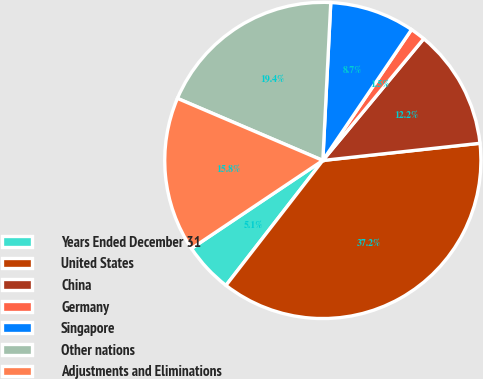<chart> <loc_0><loc_0><loc_500><loc_500><pie_chart><fcel>Years Ended December 31<fcel>United States<fcel>China<fcel>Germany<fcel>Singapore<fcel>Other nations<fcel>Adjustments and Eliminations<nl><fcel>5.11%<fcel>37.23%<fcel>12.25%<fcel>1.54%<fcel>8.68%<fcel>19.38%<fcel>15.82%<nl></chart> 